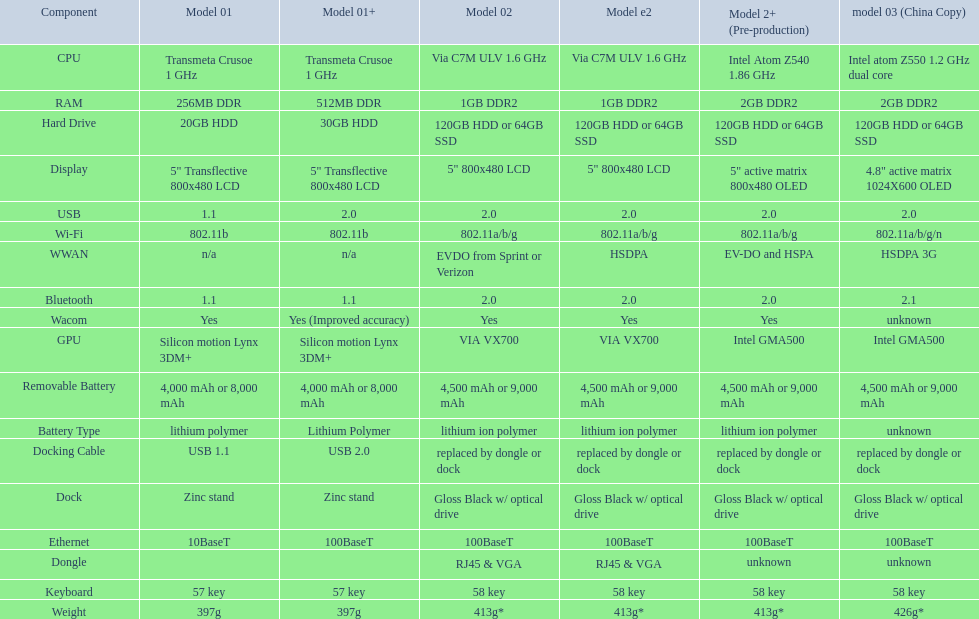What is the part prior to usb? Display. 